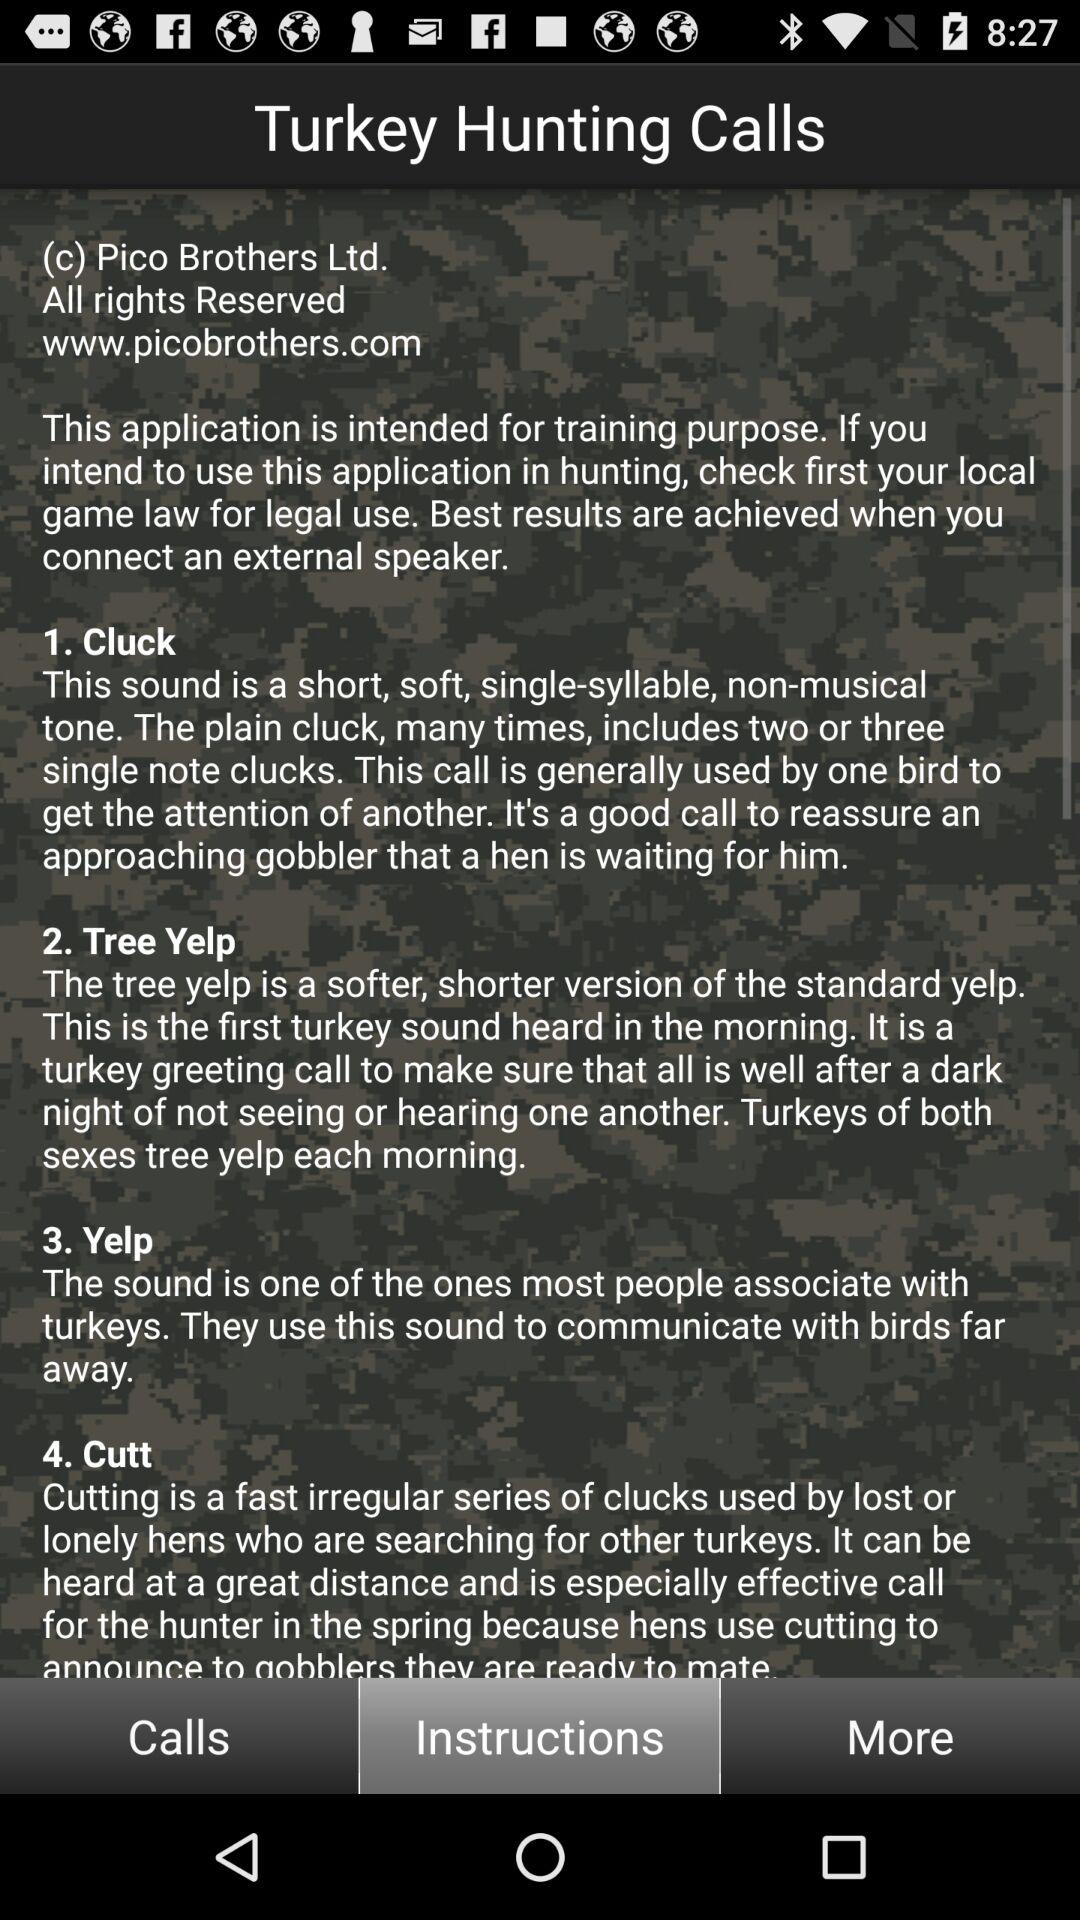What is the name of the application? The name of the application is "Turkey Hunting Calls". 